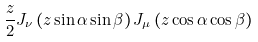Convert formula to latex. <formula><loc_0><loc_0><loc_500><loc_500>\frac { z } { 2 } J _ { \nu } \left ( z \sin \alpha \sin \beta \right ) J _ { \mu } \left ( z \cos \alpha \cos \beta \right )</formula> 